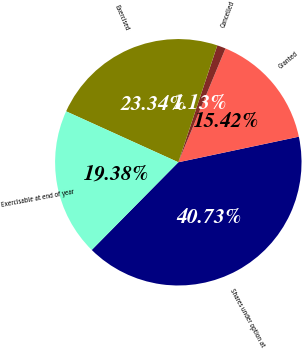Convert chart to OTSL. <chart><loc_0><loc_0><loc_500><loc_500><pie_chart><fcel>Shares under option at<fcel>Granted<fcel>Cancelled<fcel>Exercised<fcel>Exercisable at end of year<nl><fcel>40.73%<fcel>15.42%<fcel>1.13%<fcel>23.34%<fcel>19.38%<nl></chart> 